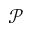Convert formula to latex. <formula><loc_0><loc_0><loc_500><loc_500>\mathcal { P }</formula> 